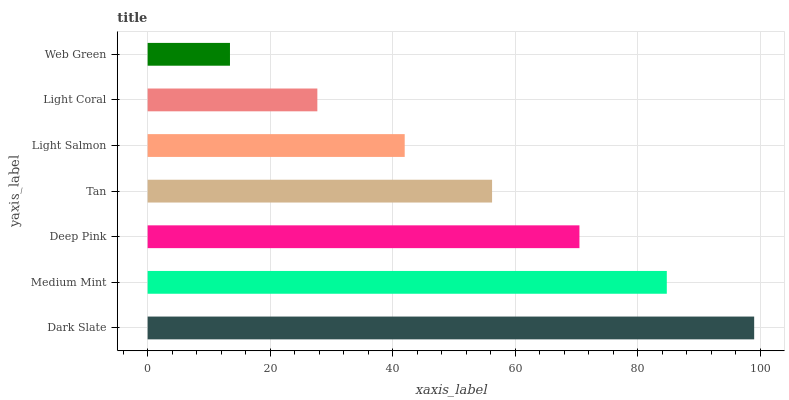Is Web Green the minimum?
Answer yes or no. Yes. Is Dark Slate the maximum?
Answer yes or no. Yes. Is Medium Mint the minimum?
Answer yes or no. No. Is Medium Mint the maximum?
Answer yes or no. No. Is Dark Slate greater than Medium Mint?
Answer yes or no. Yes. Is Medium Mint less than Dark Slate?
Answer yes or no. Yes. Is Medium Mint greater than Dark Slate?
Answer yes or no. No. Is Dark Slate less than Medium Mint?
Answer yes or no. No. Is Tan the high median?
Answer yes or no. Yes. Is Tan the low median?
Answer yes or no. Yes. Is Light Coral the high median?
Answer yes or no. No. Is Medium Mint the low median?
Answer yes or no. No. 